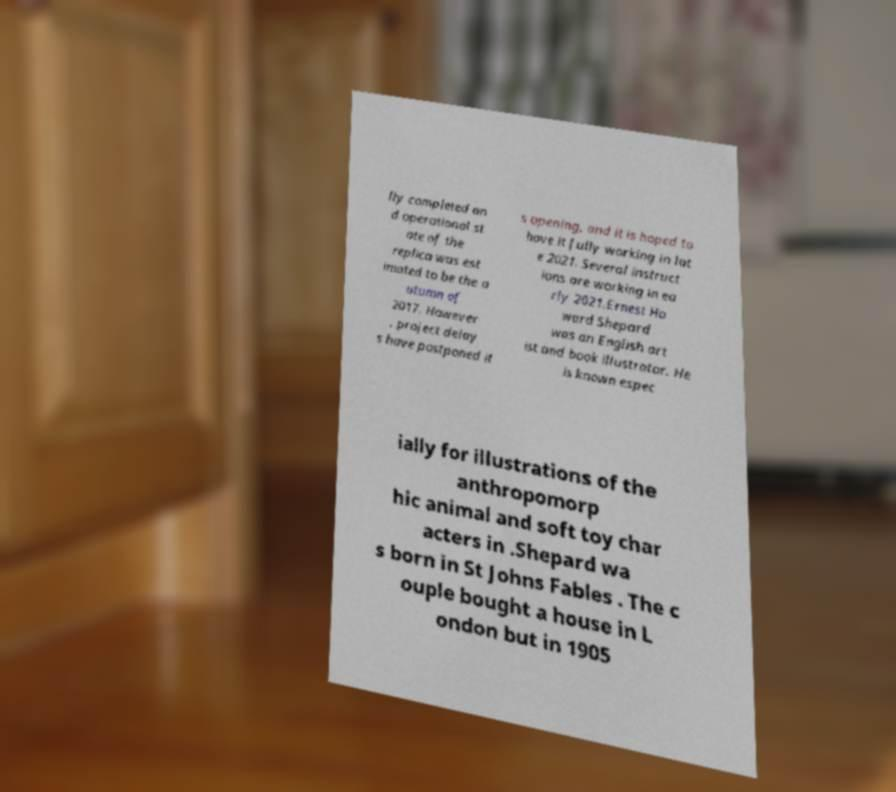For documentation purposes, I need the text within this image transcribed. Could you provide that? lly completed an d operational st ate of the replica was est imated to be the a utumn of 2017. However , project delay s have postponed it s opening, and it is hoped to have it fully working in lat e 2021. Several instruct ions are working in ea rly 2021.Ernest Ho ward Shepard was an English art ist and book illustrator. He is known espec ially for illustrations of the anthropomorp hic animal and soft toy char acters in .Shepard wa s born in St Johns Fables . The c ouple bought a house in L ondon but in 1905 